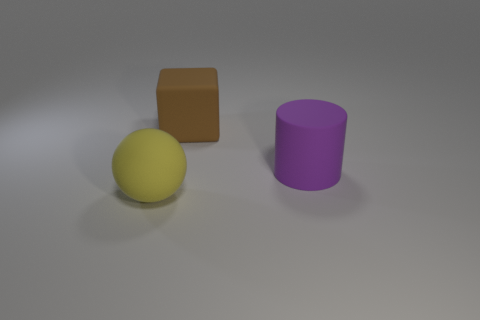Add 2 small green things. How many objects exist? 5 Subtract 1 purple cylinders. How many objects are left? 2 Subtract all balls. How many objects are left? 2 Subtract all gray cylinders. Subtract all gray balls. How many cylinders are left? 1 Subtract all large green rubber things. Subtract all brown objects. How many objects are left? 2 Add 3 big purple rubber cylinders. How many big purple rubber cylinders are left? 4 Add 1 big purple cylinders. How many big purple cylinders exist? 2 